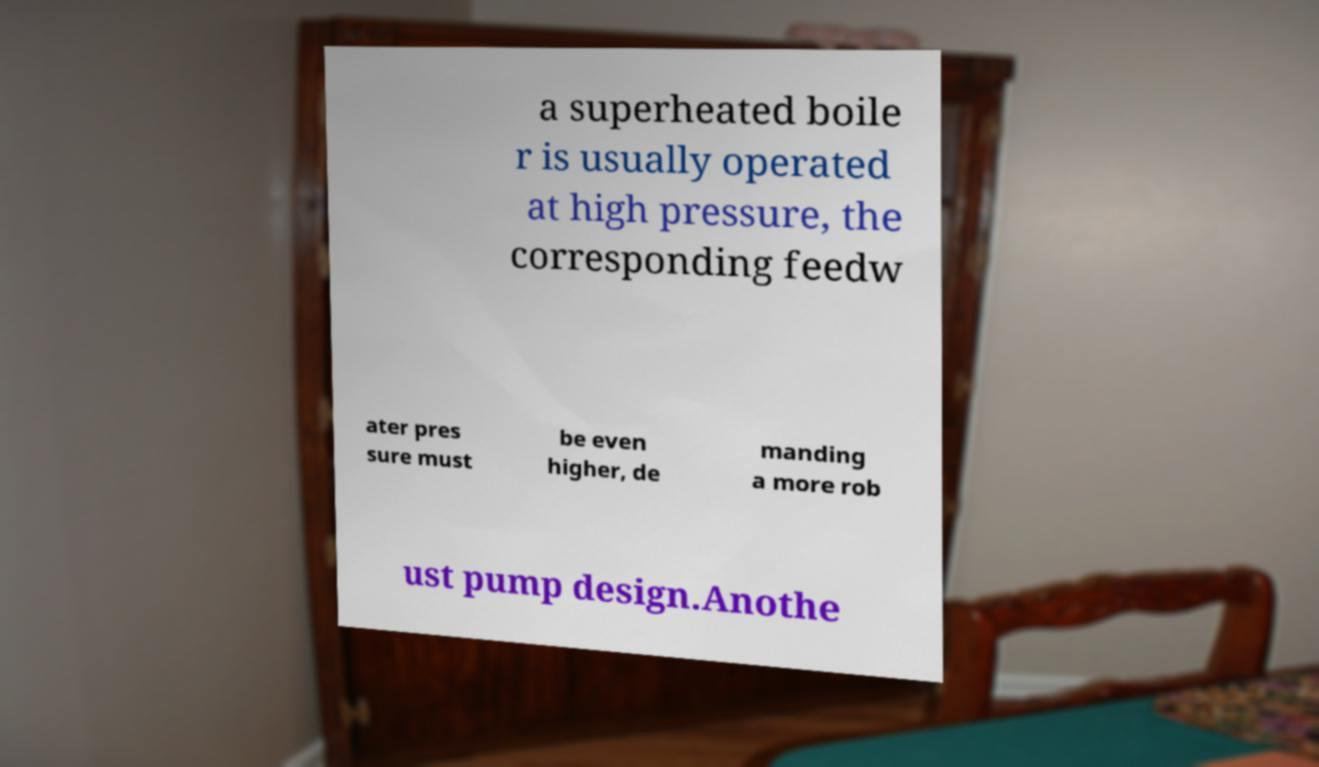Can you read and provide the text displayed in the image?This photo seems to have some interesting text. Can you extract and type it out for me? a superheated boile r is usually operated at high pressure, the corresponding feedw ater pres sure must be even higher, de manding a more rob ust pump design.Anothe 